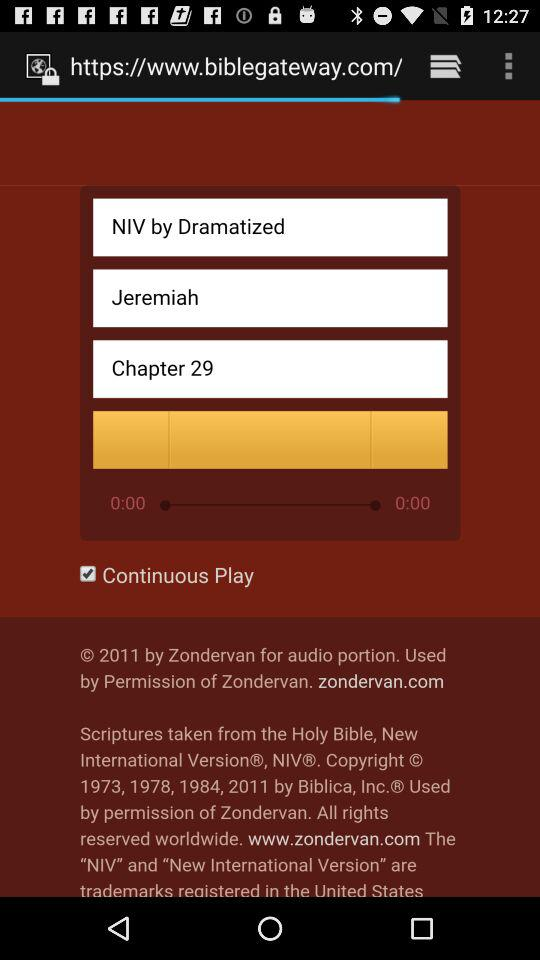Who dramatized the chapter?
When the provided information is insufficient, respond with <no answer>. <no answer> 